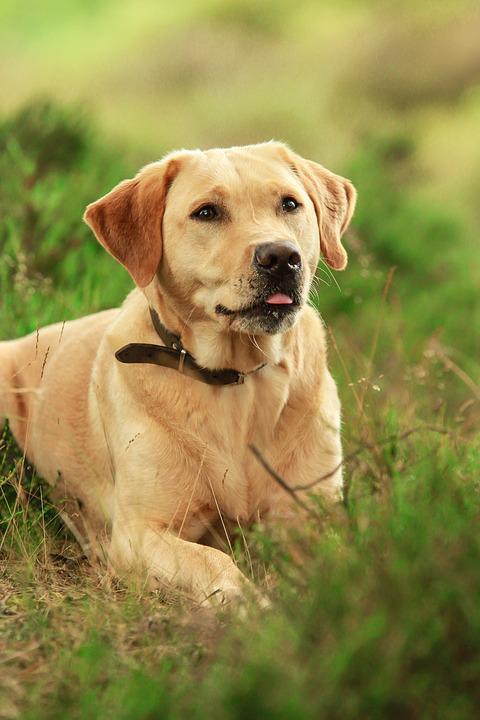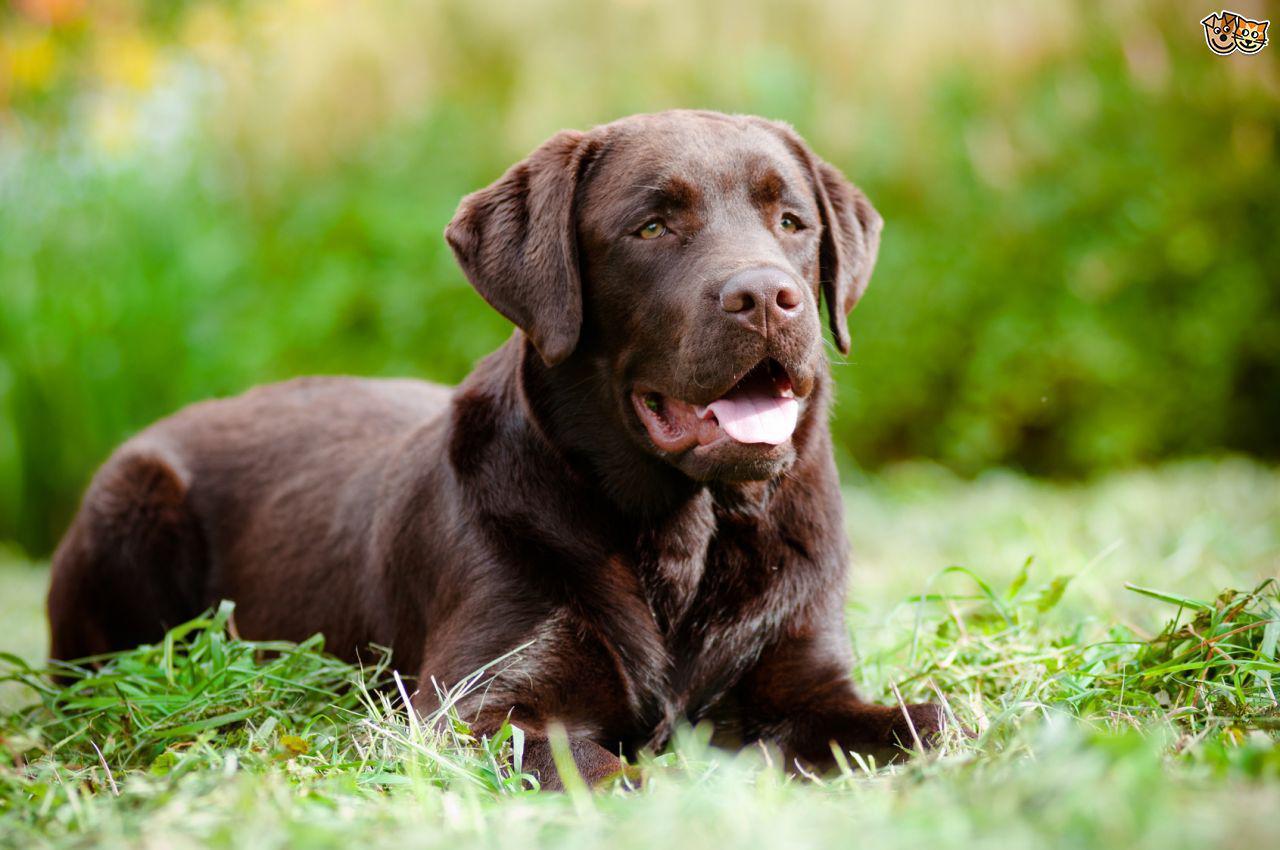The first image is the image on the left, the second image is the image on the right. Given the left and right images, does the statement "There is exactly one adult dog lying in the grass." hold true? Answer yes or no. No. 